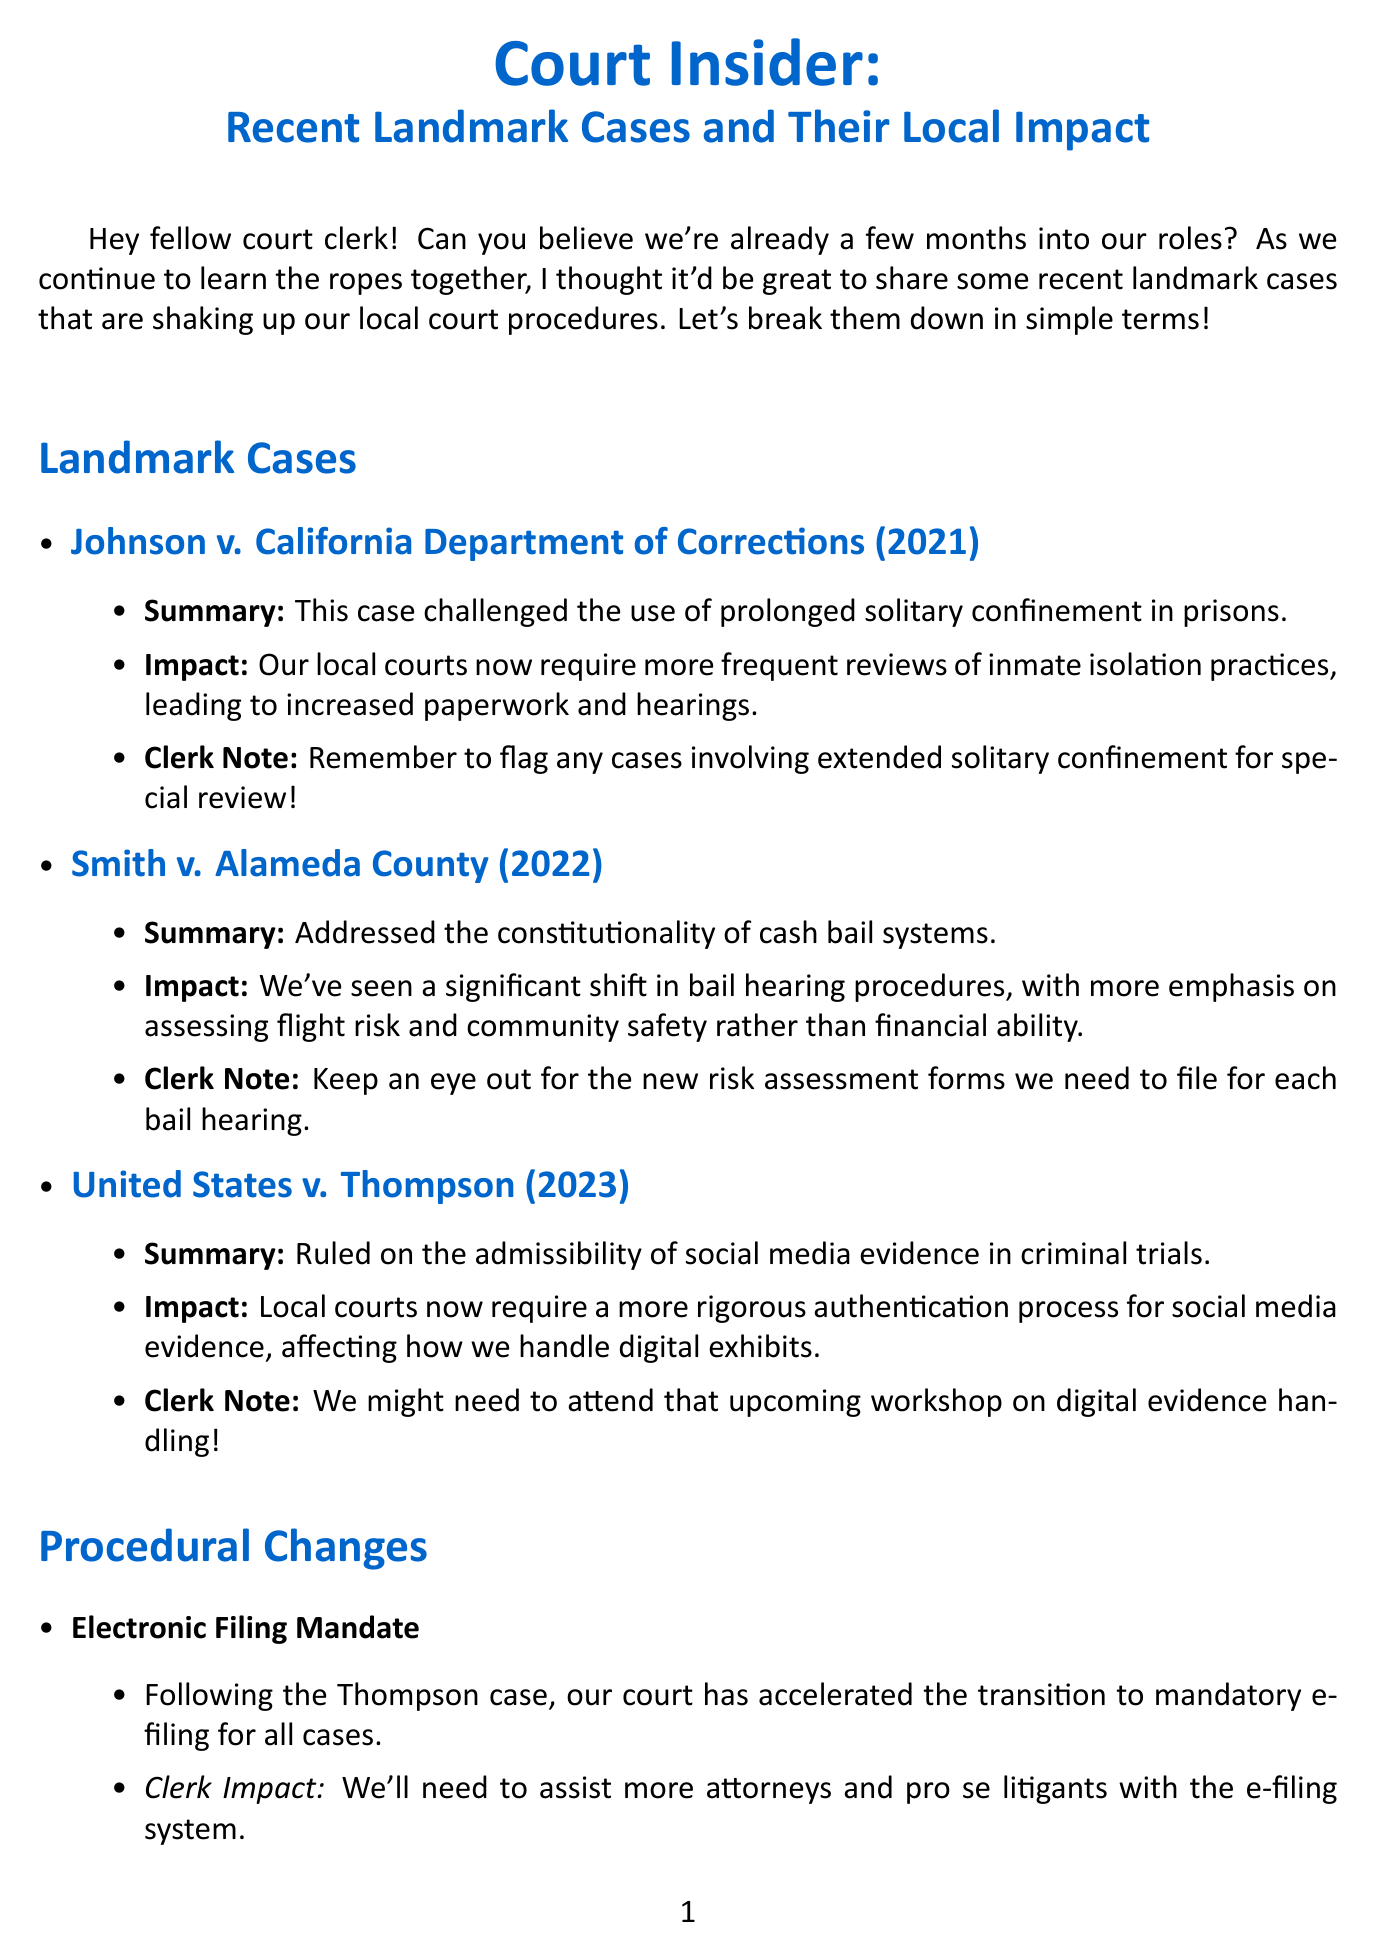What is the title of the newsletter? The title of the newsletter is presented prominently at the beginning of the document.
Answer: Court Insider: Recent Landmark Cases and Their Local Impact How many landmark cases are discussed in the newsletter? The number of landmark cases is specified under the section "Landmark Cases" in the document.
Answer: Three What year was Johnson v. California Department of Corrections decided? The year of the Johnson case is included in the document alongside the case name.
Answer: 2021 What does the Smith v. Alameda County case address? The specific issue addressed by the Smith case is stated in its summary section.
Answer: Cash bail systems What change was made to bail hearing procedures following the Smith case? The document mentions the emphasis on assessing rather than financial ability.
Answer: Flight risk and community safety What is the upcoming training topic mentioned in the newsletter? The specific topic for the upcoming training is stated towards the end of the document.
Answer: Digital Evidence Handling in the Modern Courtroom Which case requires more frequent reviews of inmate isolation practices? The impact of this case is detailed in its summary.
Answer: Johnson v. California Department of Corrections What are local courts now required to authenticate more rigorously? The item that requires rigorous authentication is mentioned in the appropriate case summary.
Answer: Social media evidence What procedural change affects the electronic filing system? The description of the change due to the Thompson case indicates this.
Answer: Mandatory e-filing 